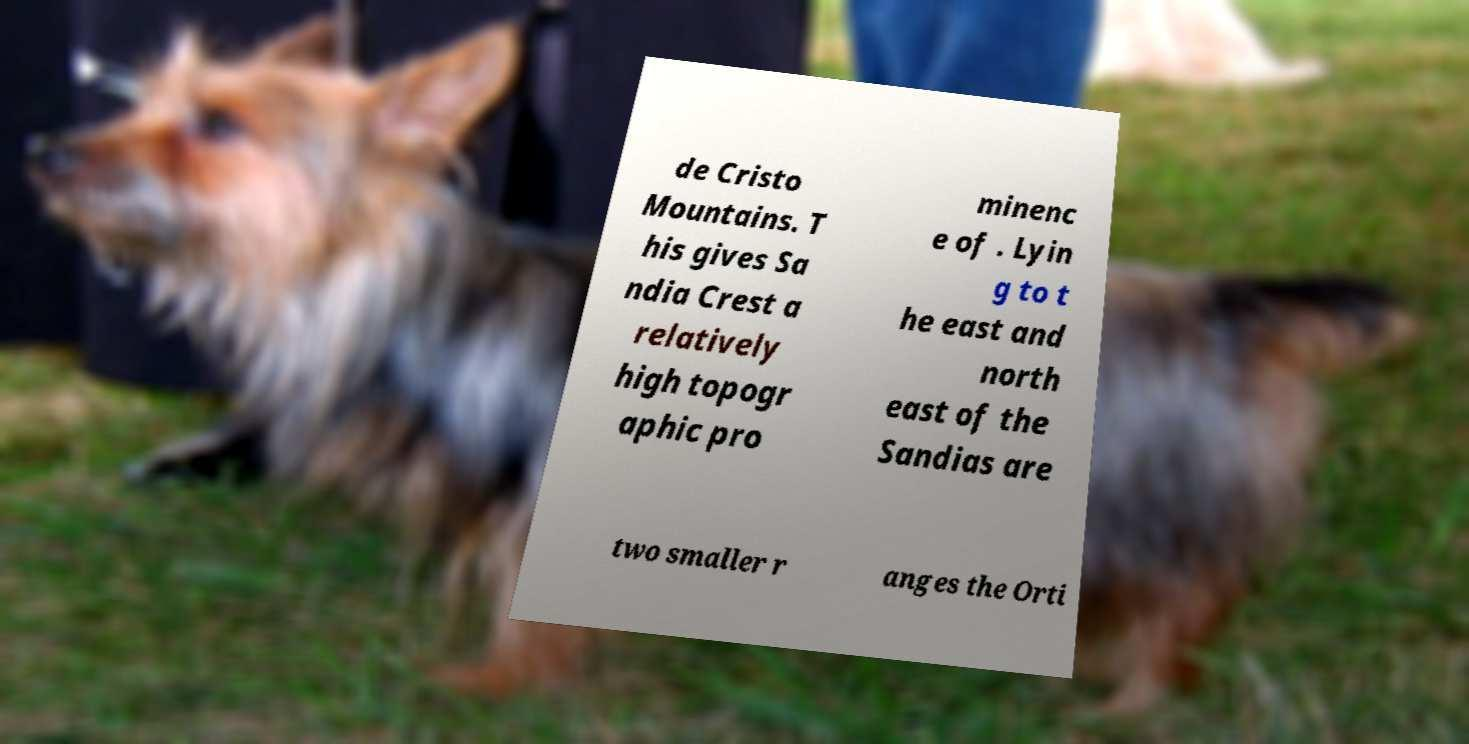There's text embedded in this image that I need extracted. Can you transcribe it verbatim? de Cristo Mountains. T his gives Sa ndia Crest a relatively high topogr aphic pro minenc e of . Lyin g to t he east and north east of the Sandias are two smaller r anges the Orti 